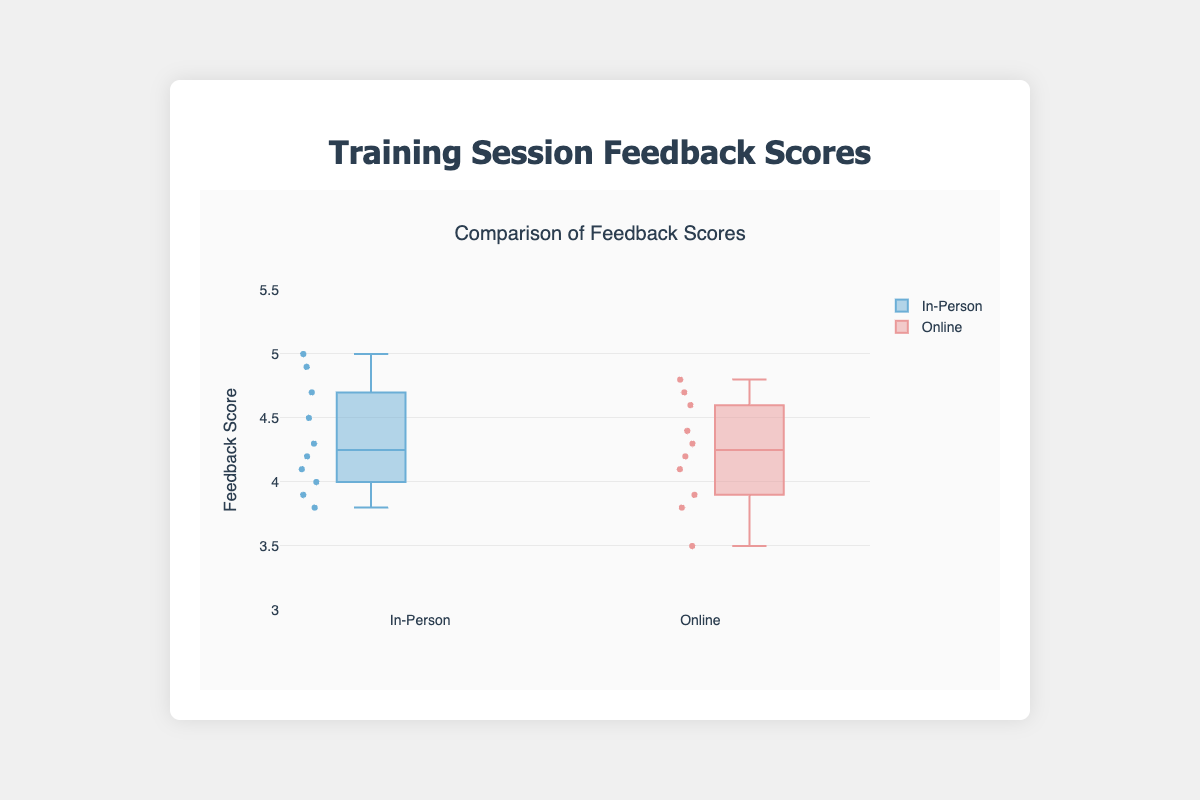What's the title of the plot? The title of the plot is usually prominently displayed at the top of the figure. It's used to give viewers a quick idea of what the data visualization is about. In this case, the title reads "Comparison of Feedback Scores".
Answer: Comparison of Feedback Scores What is the range of the y-axis? To find the range of the y-axis, you need to look at the lowest and highest values indicated on the axis. The y-axis range here is from 3 to 5.5.
Answer: 3 to 5.5 Which session type has a higher median feedback score? To determine this, observe the line inside each box. The line represents the median score. The in-person session has a median line higher than the online session.
Answer: In-person Which session type shows more variability in feedback scores? Variability in a box plot can be assessed by the length of the box and the whiskers. The online session has longer boxes and whiskers, indicating more variability.
Answer: Online How does the highest feedback score compare between the session types? The highest feedback score is represented by the topmost point or end of the upper whisker. Both session types extend to the same highest score of 5.0.
Answer: Equal What's the interquartile range (IQR) for the in-person session? The IQR is calculated as the difference between the upper quartile (75th percentile) and the lower quartile (25th percentile). From the plot, this can be visually estimated. If we assume the 75th percentile is around 4.7 and the 25th is around 4.1, we get 4.7 - 4.1 = 0.6.
Answer: 0.6 What is the median value for the online session? The median value is represented by the line inside the box for the online session. It appears to be approximately 4.3.
Answer: 4.3 Are there any outliers in the feedback scores for either session type? Outliers are typically shown as individual points outside the whiskers in a box plot, representing data points that are significantly higher or lower than the rest. There are no outliers shown in either session type.
Answer: No What is the lowest feedback score for the online session? The lowest feedback score is represented by the bottom whisker of the box plot for the online session. It is approximately 3.5.
Answer: 3.5 